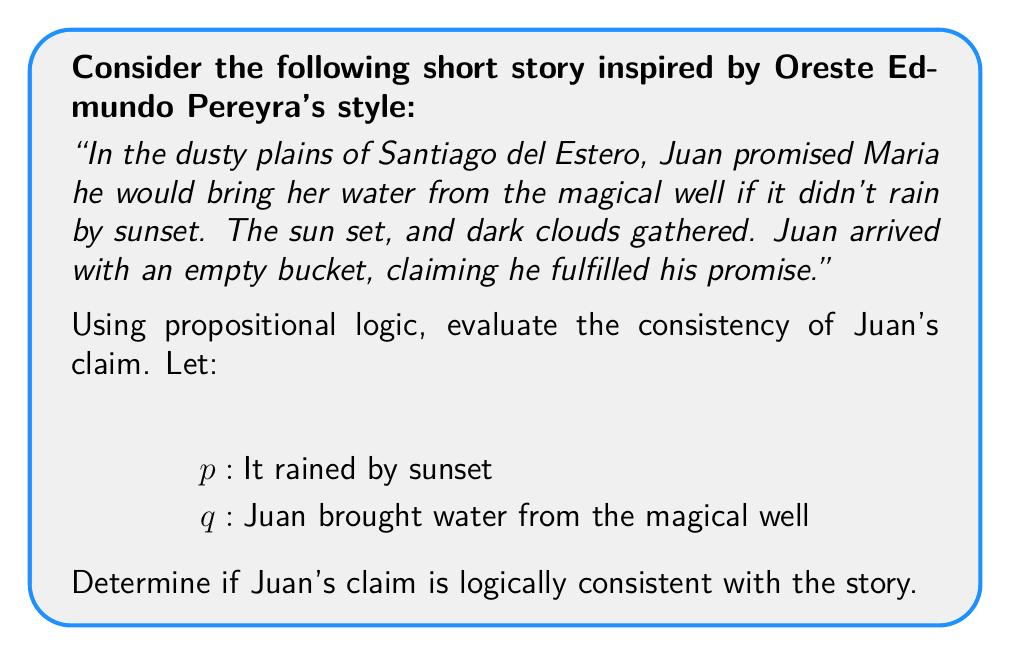Could you help me with this problem? Let's approach this step-by-step using propositional logic:

1) Juan's promise can be represented as: $p \rightarrow \neg q$
   (If it rains by sunset, then Juan won't bring water)

2) The negation of this implication is: $p \land q$
   (It rains by sunset and Juan brings water)

3) From the story, we know:
   - The sun set and dark clouds gathered, but it's not explicitly stated that it rained. So we can't determine the truth value of $p$.
   - Juan arrived with an empty bucket, so $\neg q$ is true.

4) Juan claims he fulfilled his promise. For this to be true, either:
   a) $p$ is true (it rained), so he didn't need to bring water, or
   b) $p$ is false (it didn't rain) and $q$ is true (he brought water)

5) However, we know $\neg q$ is true (he didn't bring water).

6) This means the only consistent scenario is:
   $p \land \neg q$ (It rained and Juan didn't bring water)

7) This scenario satisfies the original implication $p \rightarrow \neg q$

Therefore, Juan's claim is logically consistent with the story, but only if it actually rained (which is implied but not explicitly stated).
Answer: Consistent, if $p$ is true. 